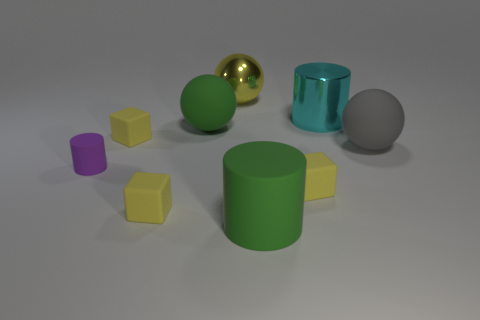How many things are either small yellow rubber cubes or large gray cubes?
Give a very brief answer. 3. Does the small purple rubber object have the same shape as the large cyan shiny thing?
Keep it short and to the point. Yes. What material is the cyan cylinder?
Offer a terse response. Metal. How many rubber things are both to the right of the cyan shiny thing and to the left of the large cyan metallic object?
Your answer should be compact. 0. Do the gray ball and the green matte cylinder have the same size?
Make the answer very short. Yes. There is a yellow block to the right of the shiny sphere; is it the same size as the gray sphere?
Give a very brief answer. No. There is a large matte object in front of the large gray matte thing; what is its color?
Provide a short and direct response. Green. What number of cyan rubber cylinders are there?
Make the answer very short. 0. What shape is the large green thing that is made of the same material as the large green sphere?
Your answer should be compact. Cylinder. There is a rubber ball that is to the left of the large yellow thing; is its color the same as the sphere behind the cyan cylinder?
Your answer should be very brief. No. 